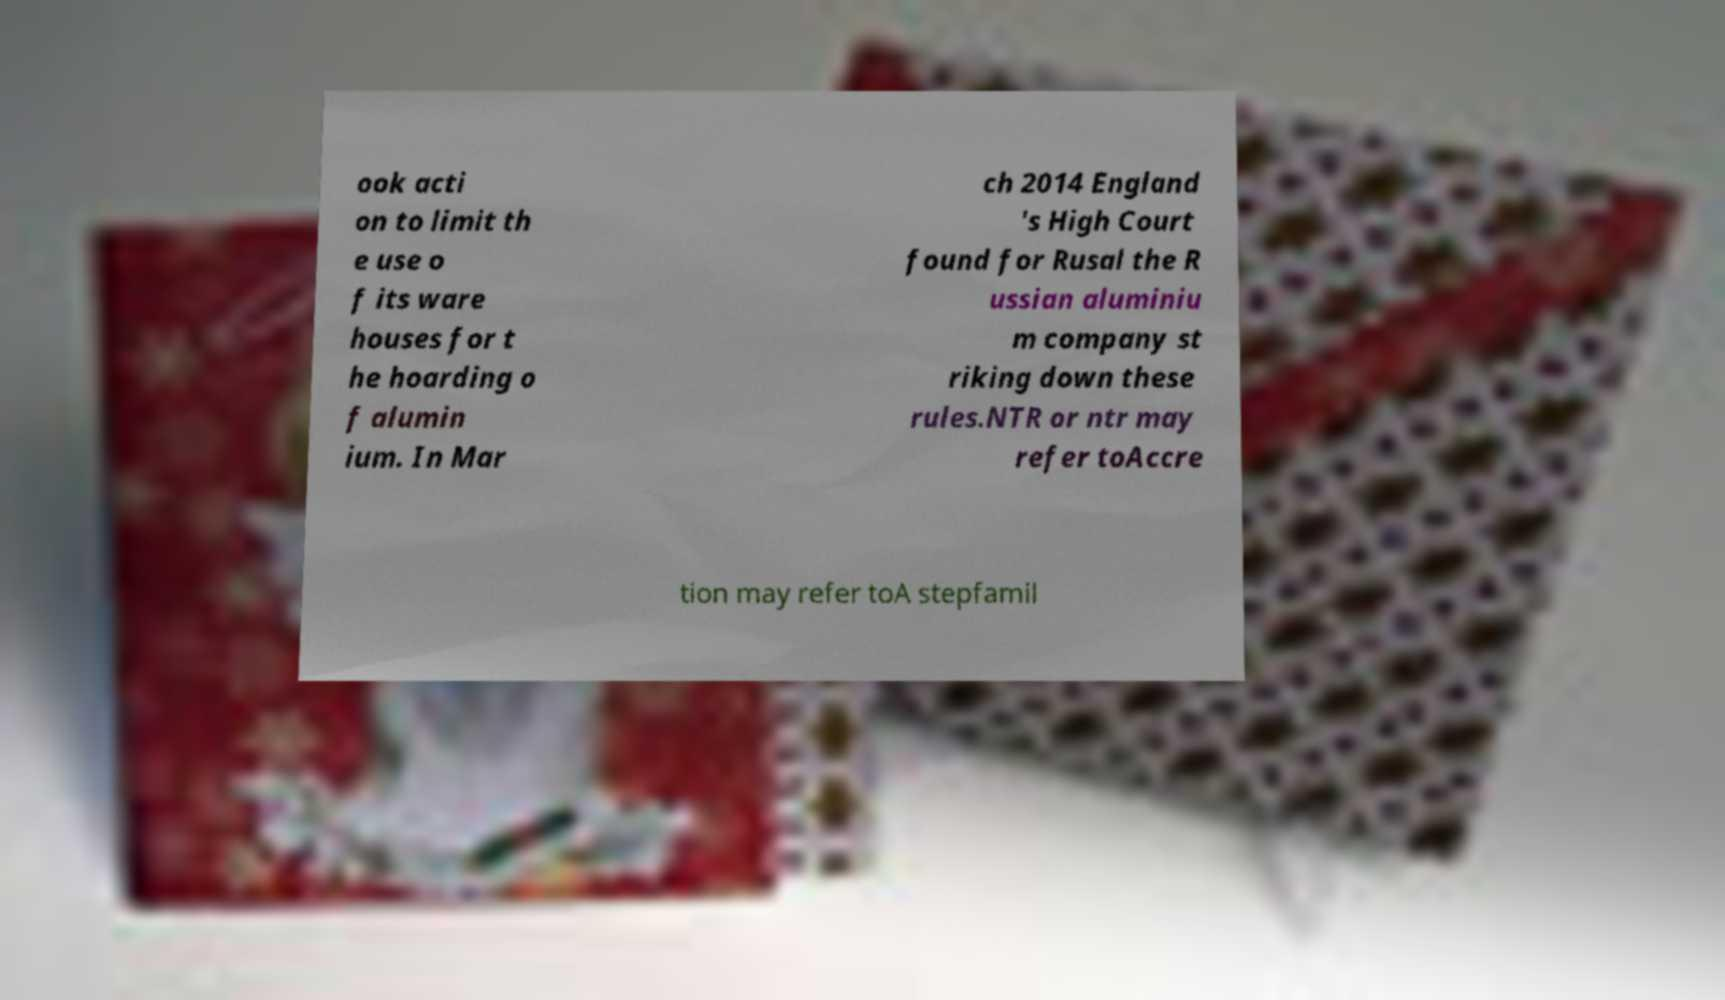There's text embedded in this image that I need extracted. Can you transcribe it verbatim? ook acti on to limit th e use o f its ware houses for t he hoarding o f alumin ium. In Mar ch 2014 England 's High Court found for Rusal the R ussian aluminiu m company st riking down these rules.NTR or ntr may refer toAccre tion may refer toA stepfamil 